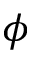Convert formula to latex. <formula><loc_0><loc_0><loc_500><loc_500>\phi</formula> 